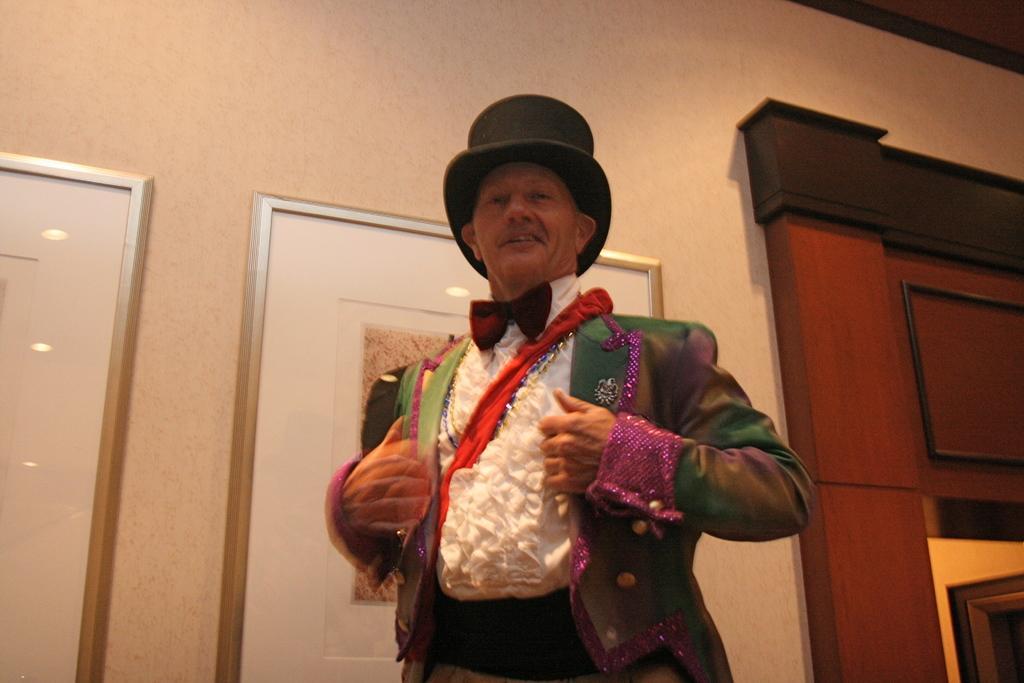Describe this image in one or two sentences. In the front of the image I can see a person is standing and wore a hat. In the background of the image there is wall, pictures and objects. Pictures are on the wall. 